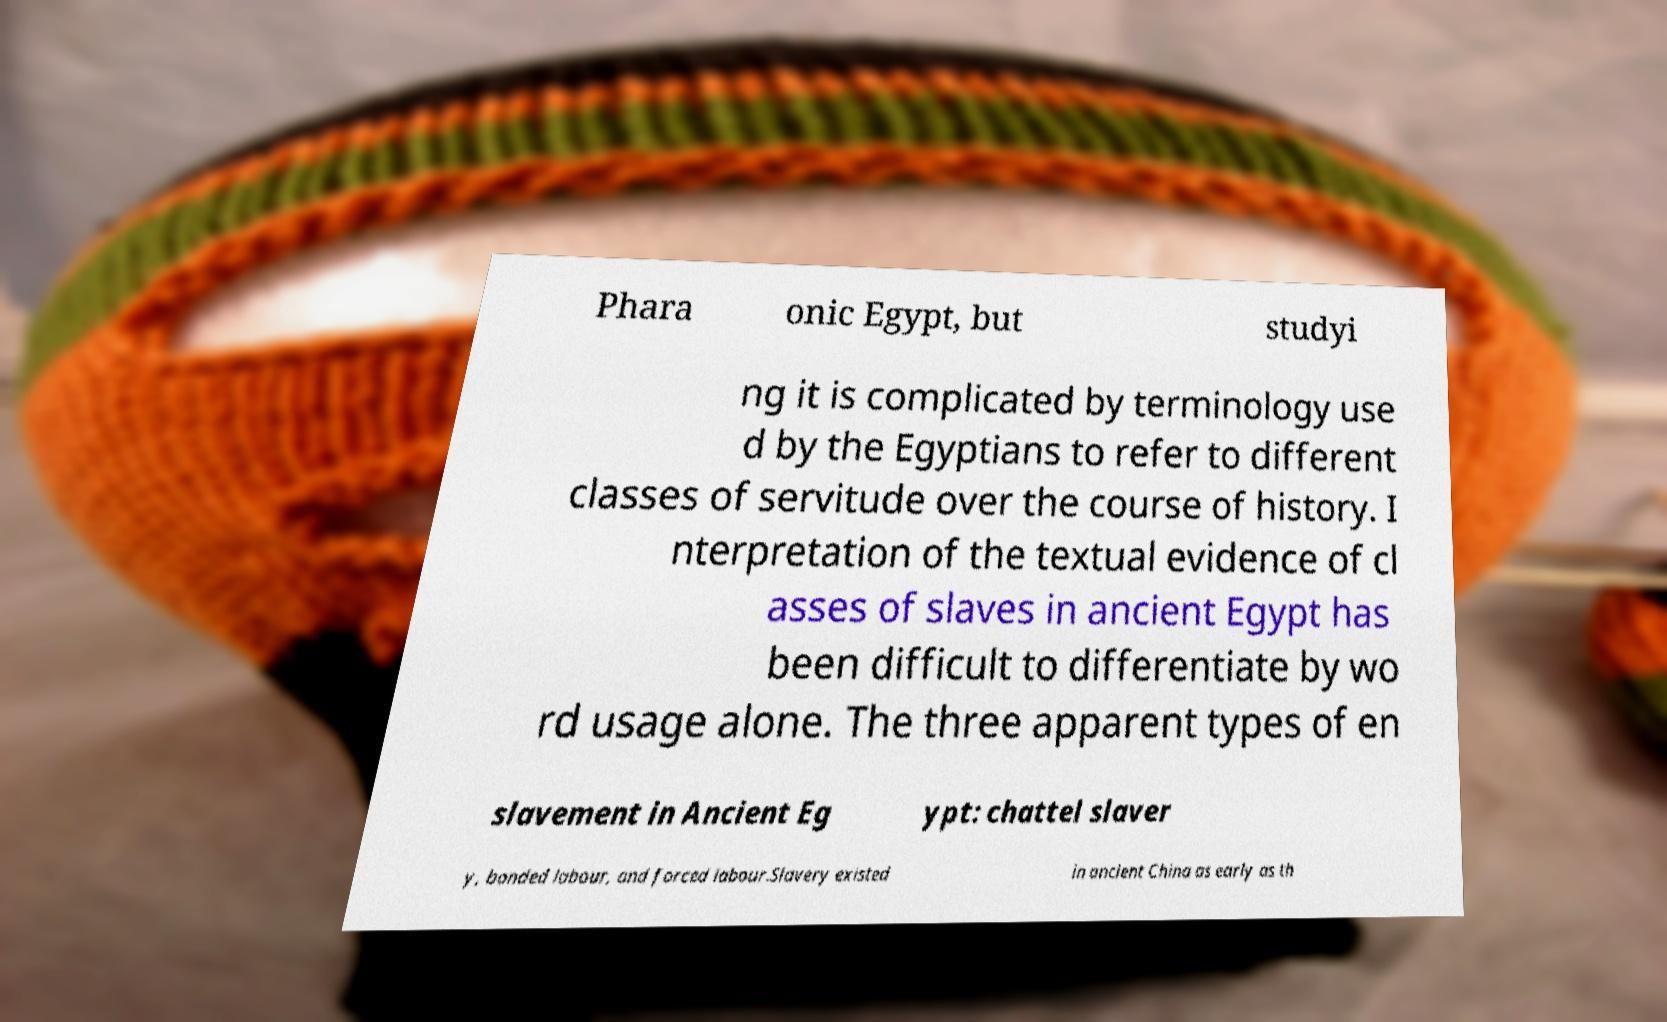What messages or text are displayed in this image? I need them in a readable, typed format. Phara onic Egypt, but studyi ng it is complicated by terminology use d by the Egyptians to refer to different classes of servitude over the course of history. I nterpretation of the textual evidence of cl asses of slaves in ancient Egypt has been difficult to differentiate by wo rd usage alone. The three apparent types of en slavement in Ancient Eg ypt: chattel slaver y, bonded labour, and forced labour.Slavery existed in ancient China as early as th 